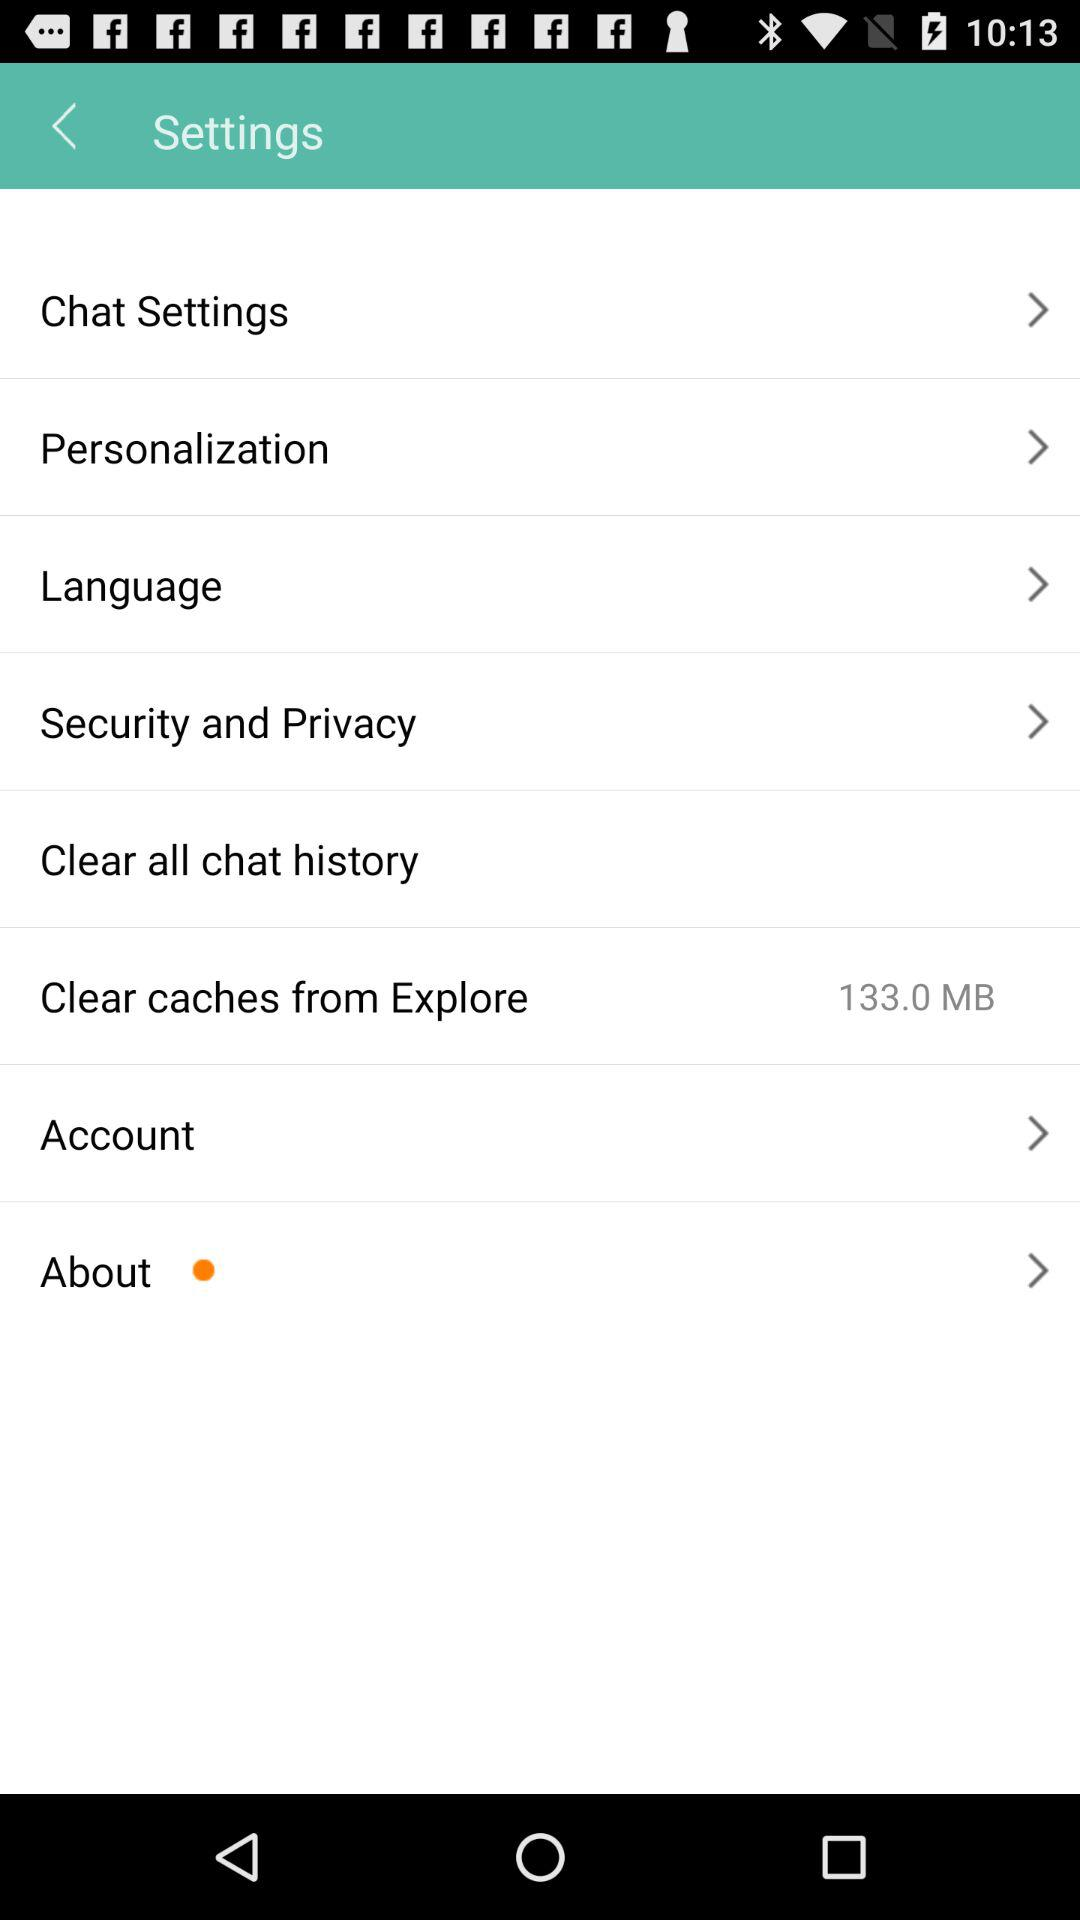What is the size of the data shown in "Clear caches from Explore"? The size of the data shown in "Clear caches from Explore" is 133.0 MB. 